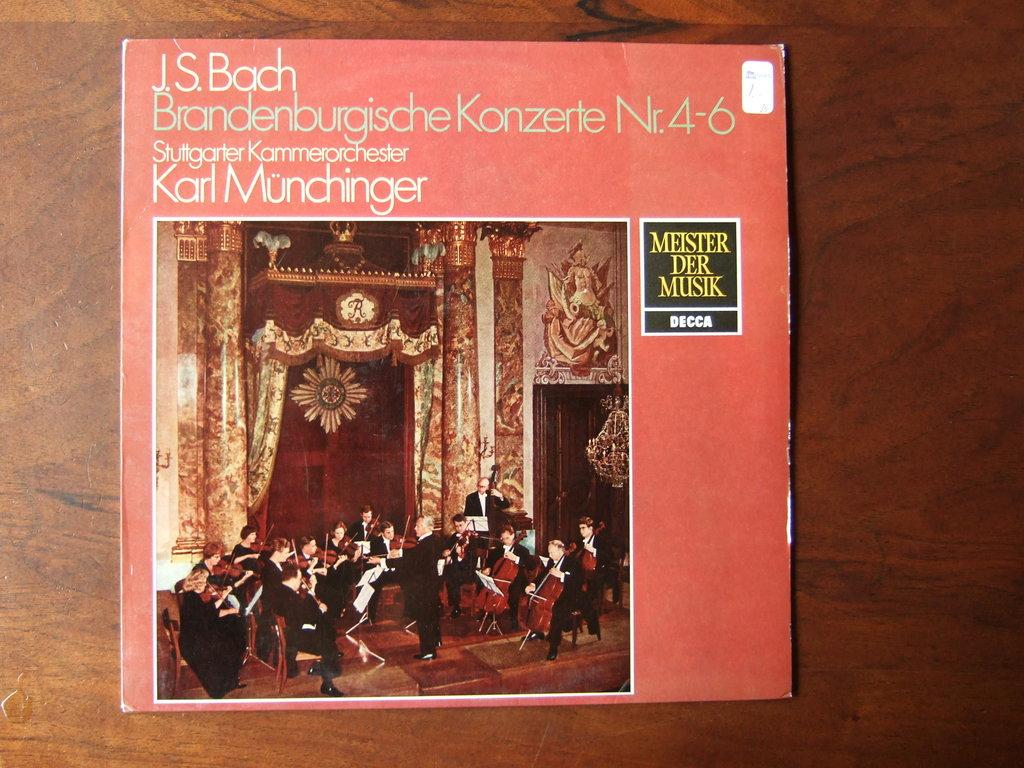Who composed the music on this album?
Your response must be concise. J.s. bach. What numbers are on the album?
Your answer should be very brief. 4-6. 